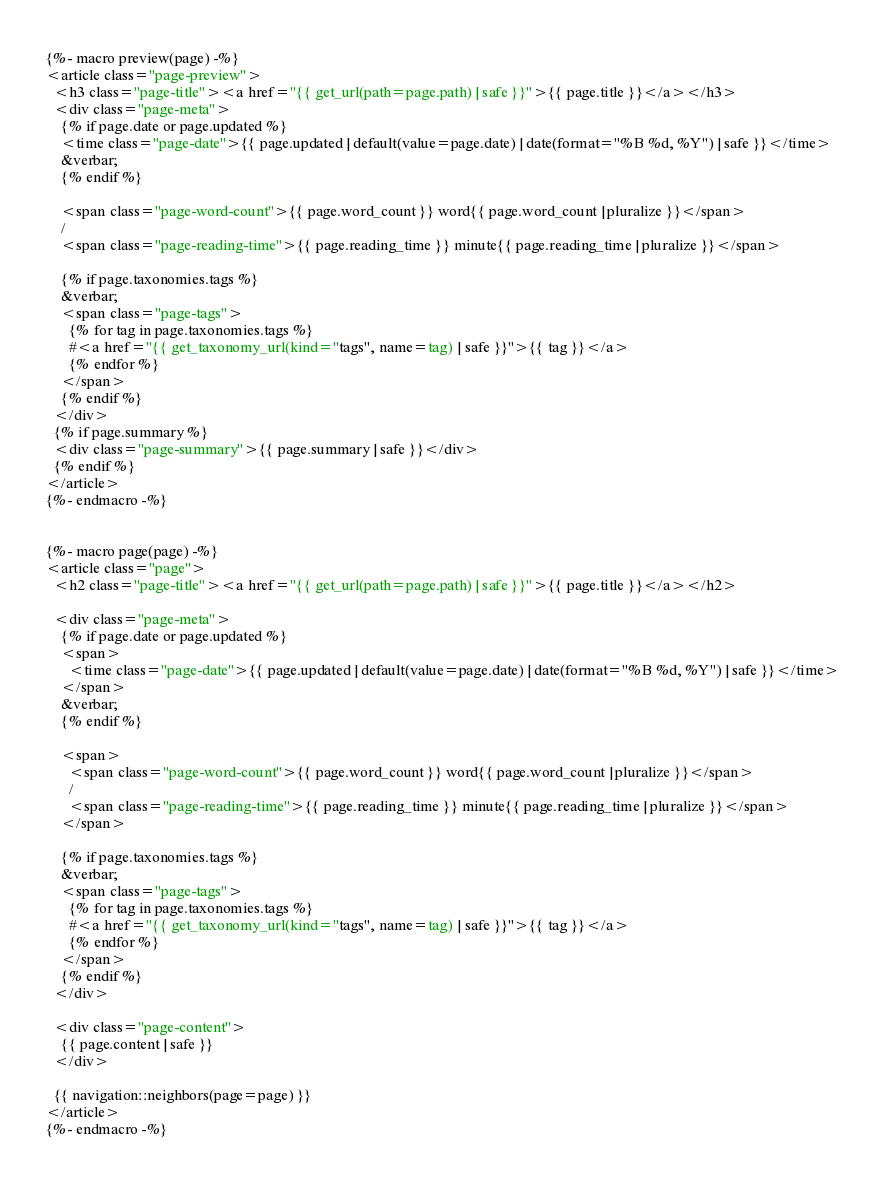<code> <loc_0><loc_0><loc_500><loc_500><_HTML_>
{%- macro preview(page) -%}
<article class="page-preview">
  <h3 class="page-title"><a href="{{ get_url(path=page.path) | safe }}">{{ page.title }}</a></h3>
  <div class="page-meta">
    {% if page.date or page.updated %}
    <time class="page-date">{{ page.updated | default(value=page.date) | date(format="%B %d, %Y") | safe }}</time>
    &verbar;
    {% endif %}

    <span class="page-word-count">{{ page.word_count }} word{{ page.word_count | pluralize }}</span>
    /
    <span class="page-reading-time">{{ page.reading_time }} minute{{ page.reading_time | pluralize }}</span>
    
    {% if page.taxonomies.tags %}
    &verbar;
    <span class="page-tags">
      {% for tag in page.taxonomies.tags %}
      #<a href="{{ get_taxonomy_url(kind="tags", name=tag) | safe }}">{{ tag }}</a>
      {% endfor %}
    </span>
    {% endif %}
  </div>
  {% if page.summary %}
  <div class="page-summary">{{ page.summary | safe }}</div>
  {% endif %}
</article>
{%- endmacro -%}


{%- macro page(page) -%}
<article class="page">
  <h2 class="page-title"><a href="{{ get_url(path=page.path) | safe }}">{{ page.title }}</a></h2>

  <div class="page-meta">
    {% if page.date or page.updated %}
    <span>
      <time class="page-date">{{ page.updated | default(value=page.date) | date(format="%B %d, %Y") | safe }}</time>
    </span>
    &verbar;
    {% endif %}

    <span>
      <span class="page-word-count">{{ page.word_count }} word{{ page.word_count | pluralize }}</span>
      /
      <span class="page-reading-time">{{ page.reading_time }} minute{{ page.reading_time | pluralize }}</span>
    </span>

    {% if page.taxonomies.tags %}
    &verbar;
    <span class="page-tags">
      {% for tag in page.taxonomies.tags %}
      #<a href="{{ get_taxonomy_url(kind="tags", name=tag) | safe }}">{{ tag }}</a>
      {% endfor %}
    </span>
    {% endif %}
  </div>

  <div class="page-content">
    {{ page.content | safe }}
  </div>

  {{ navigation::neighbors(page=page) }}
</article>
{%- endmacro -%}</code> 